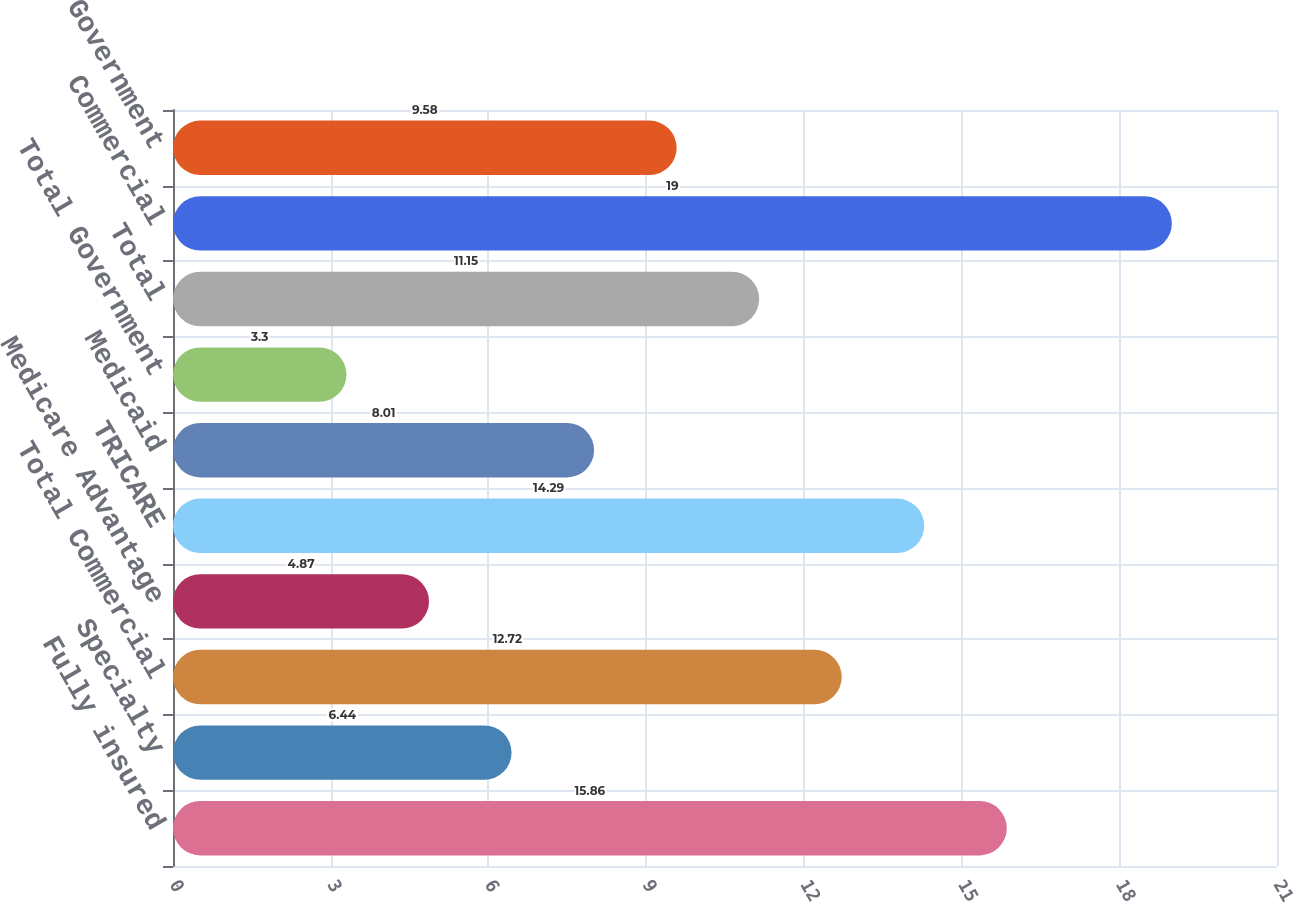<chart> <loc_0><loc_0><loc_500><loc_500><bar_chart><fcel>Fully insured<fcel>Specialty<fcel>Total Commercial<fcel>Medicare Advantage<fcel>TRICARE<fcel>Medicaid<fcel>Total Government<fcel>Total<fcel>Commercial<fcel>Government<nl><fcel>15.86<fcel>6.44<fcel>12.72<fcel>4.87<fcel>14.29<fcel>8.01<fcel>3.3<fcel>11.15<fcel>19<fcel>9.58<nl></chart> 